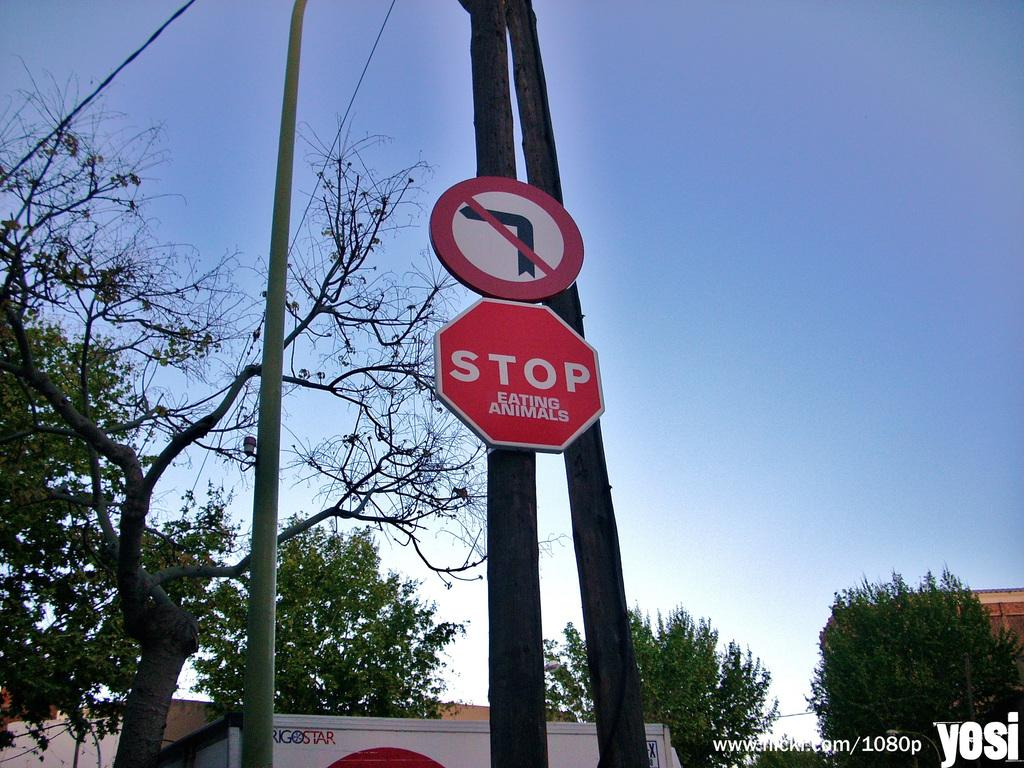<image>
Give a short and clear explanation of the subsequent image. a stop sign that is below an arrow 